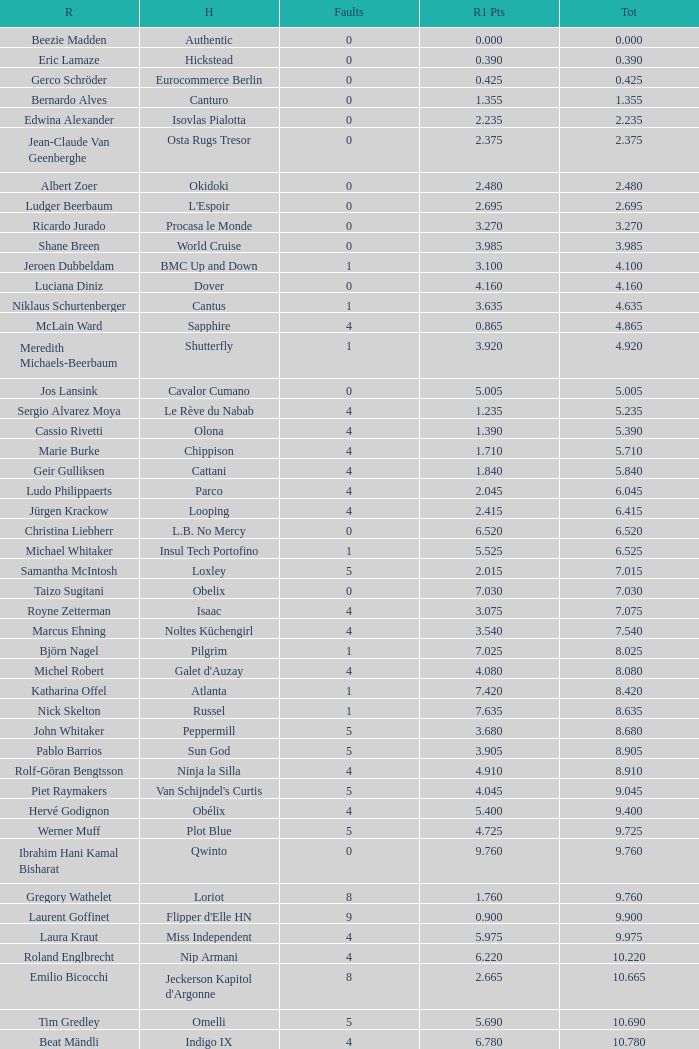Tell me the most total for horse of carlson 29.545. 